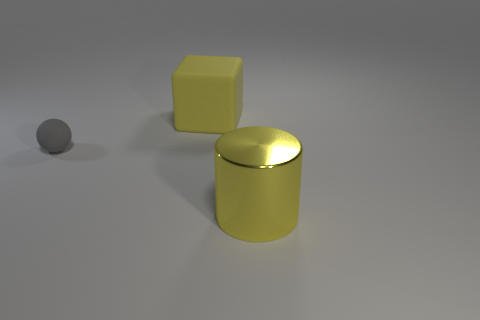Add 3 big green things. How many objects exist? 6 Subtract all cubes. How many objects are left? 2 Subtract all big yellow objects. Subtract all big yellow metal blocks. How many objects are left? 1 Add 3 big yellow shiny cylinders. How many big yellow shiny cylinders are left? 4 Add 3 big yellow spheres. How many big yellow spheres exist? 3 Subtract 1 gray spheres. How many objects are left? 2 